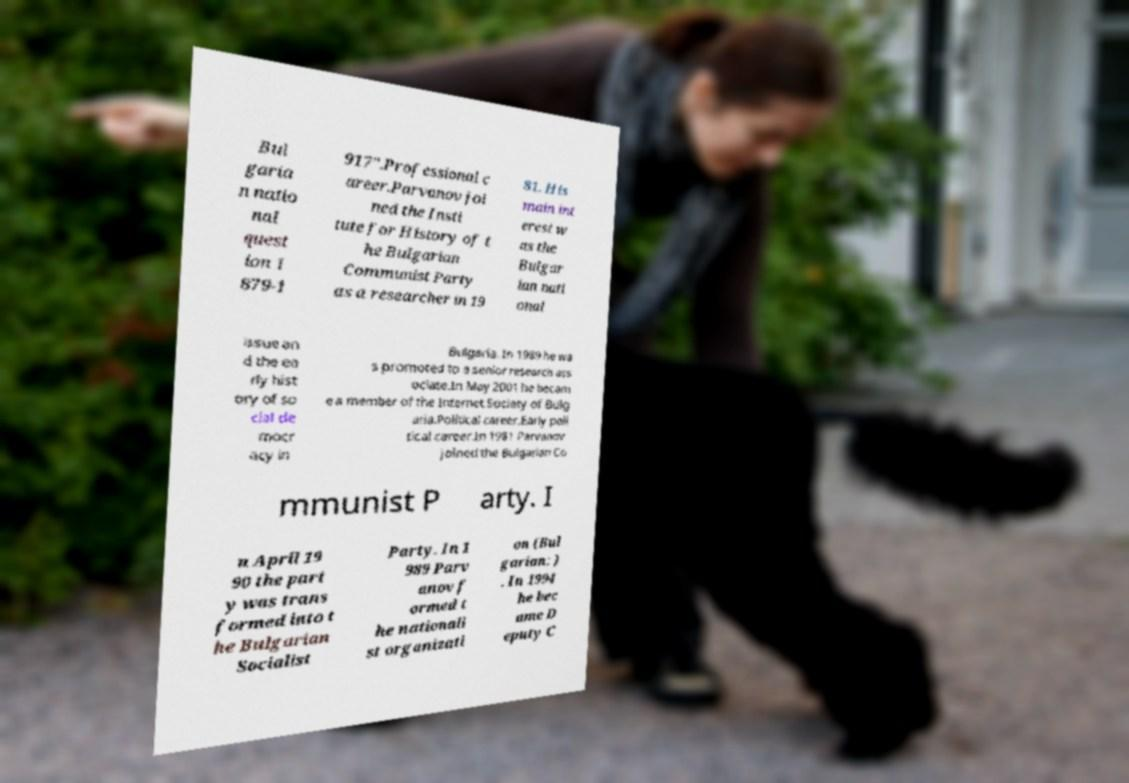Can you accurately transcribe the text from the provided image for me? Bul garia n natio nal quest ion 1 879-1 917".Professional c areer.Parvanov joi ned the Insti tute for History of t he Bulgarian Communist Party as a researcher in 19 81. His main int erest w as the Bulgar ian nati onal issue an d the ea rly hist ory of so cial de mocr acy in Bulgaria. In 1989 he wa s promoted to a senior research ass ociate.In May 2001 he becam e a member of the Internet Society of Bulg aria.Political career.Early poli tical career.In 1981 Parvanov joined the Bulgarian Co mmunist P arty. I n April 19 90 the part y was trans formed into t he Bulgarian Socialist Party. In 1 989 Parv anov f ormed t he nationali st organizati on (Bul garian: ) . In 1994 he bec ame D eputy C 